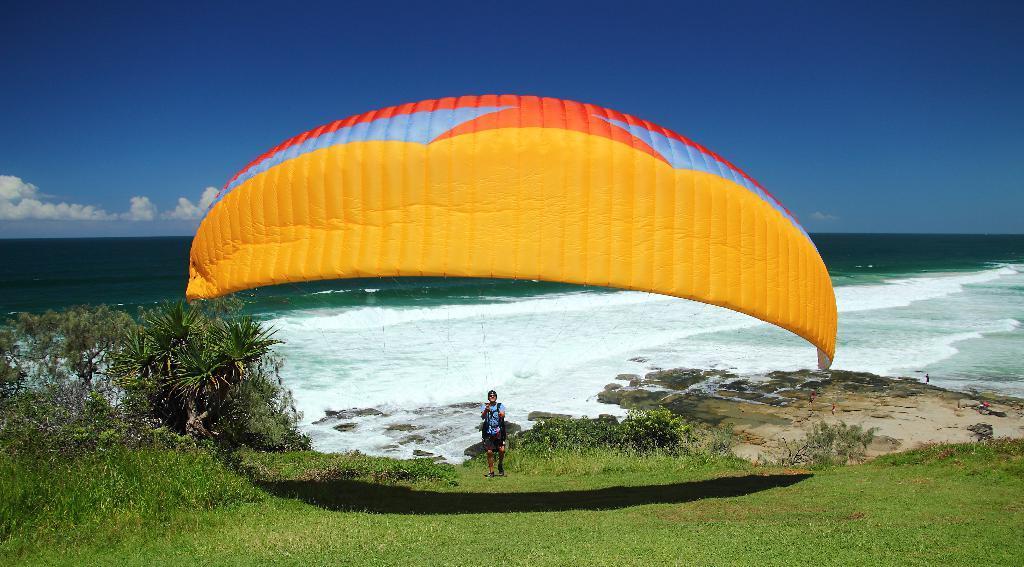In one or two sentences, can you explain what this image depicts? In this picture, there is a person holding a parachute which is in yellow and orange in color. At the bottom, there is grass. Towards the left, there are trees. In the background, there is an ocean and a sky. 